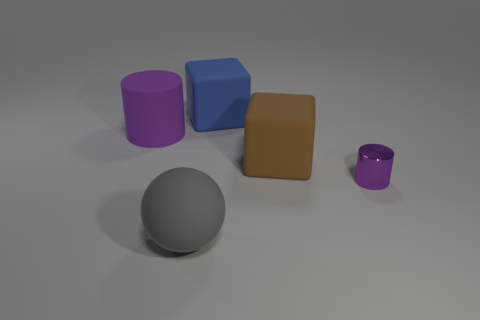Add 3 big rubber cubes. How many objects exist? 8 Subtract all balls. How many objects are left? 4 Subtract 0 cyan cylinders. How many objects are left? 5 Subtract all big purple blocks. Subtract all big matte objects. How many objects are left? 1 Add 2 blue blocks. How many blue blocks are left? 3 Add 1 tiny green balls. How many tiny green balls exist? 1 